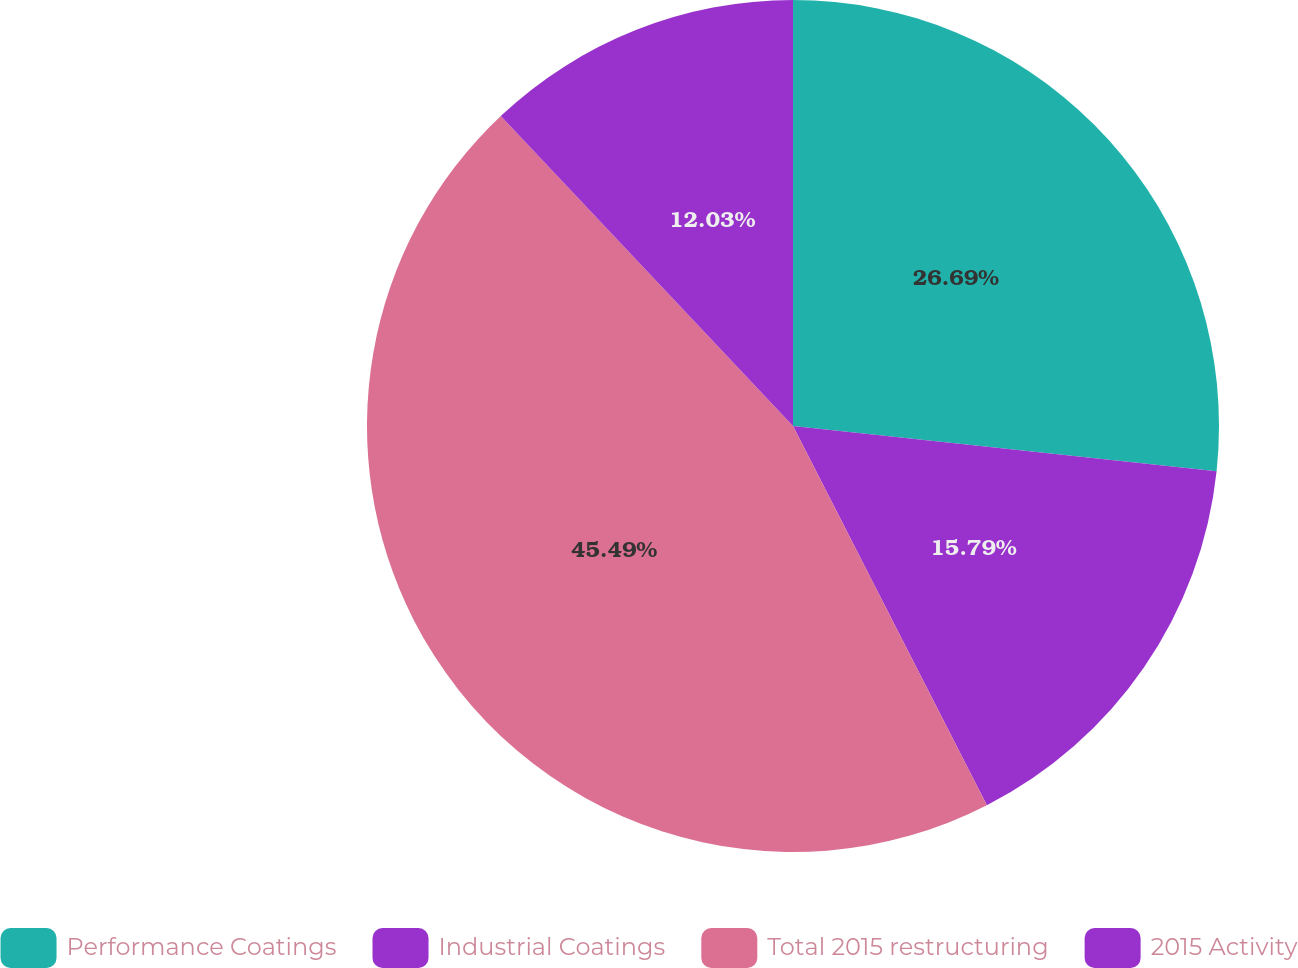Convert chart. <chart><loc_0><loc_0><loc_500><loc_500><pie_chart><fcel>Performance Coatings<fcel>Industrial Coatings<fcel>Total 2015 restructuring<fcel>2015 Activity<nl><fcel>26.69%<fcel>15.79%<fcel>45.49%<fcel>12.03%<nl></chart> 